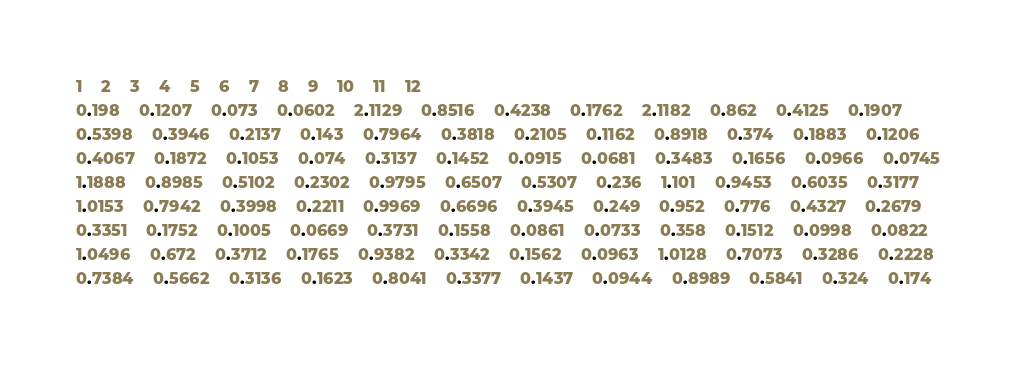Convert code to text. <code><loc_0><loc_0><loc_500><loc_500><_SQL_>1	2	3	4	5	6	7	8	9	10	11	12
0.198	0.1207	0.073	0.0602	2.1129	0.8516	0.4238	0.1762	2.1182	0.862	0.4125	0.1907
0.5398	0.3946	0.2137	0.143	0.7964	0.3818	0.2105	0.1162	0.8918	0.374	0.1883	0.1206
0.4067	0.1872	0.1053	0.074	0.3137	0.1452	0.0915	0.0681	0.3483	0.1656	0.0966	0.0745
1.1888	0.8985	0.5102	0.2302	0.9795	0.6507	0.5307	0.236	1.101	0.9453	0.6035	0.3177
1.0153	0.7942	0.3998	0.2211	0.9969	0.6696	0.3945	0.249	0.952	0.776	0.4327	0.2679
0.3351	0.1752	0.1005	0.0669	0.3731	0.1558	0.0861	0.0733	0.358	0.1512	0.0998	0.0822
1.0496	0.672	0.3712	0.1765	0.9382	0.3342	0.1562	0.0963	1.0128	0.7073	0.3286	0.2228
0.7384	0.5662	0.3136	0.1623	0.8041	0.3377	0.1437	0.0944	0.8989	0.5841	0.324	0.174
</code> 